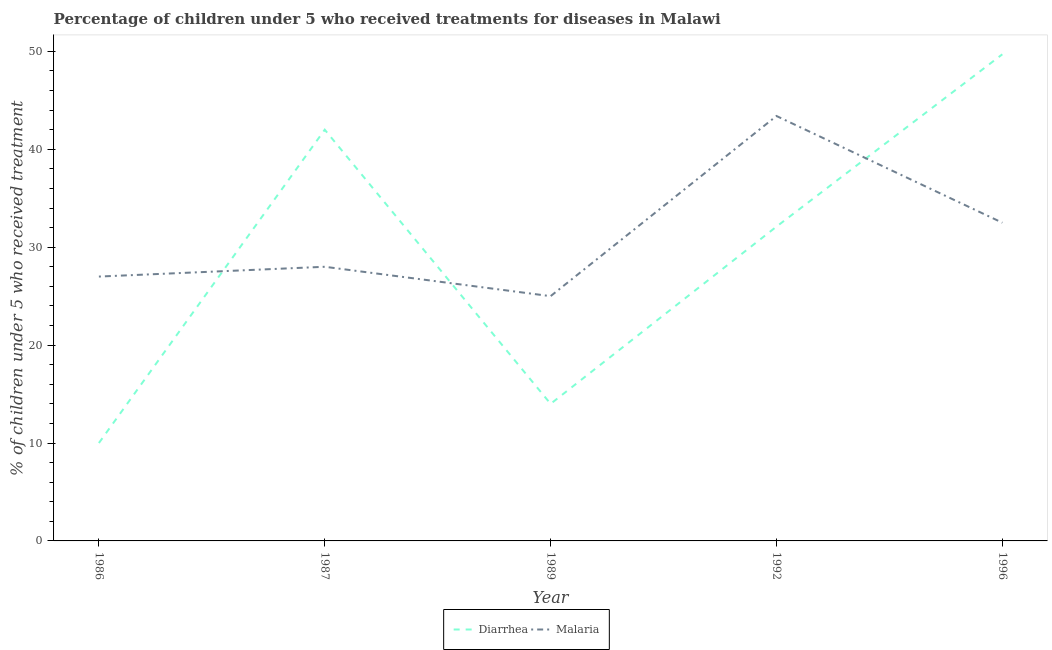Does the line corresponding to percentage of children who received treatment for malaria intersect with the line corresponding to percentage of children who received treatment for diarrhoea?
Offer a very short reply. Yes. What is the percentage of children who received treatment for diarrhoea in 1992?
Your answer should be very brief. 32.1. Across all years, what is the maximum percentage of children who received treatment for diarrhoea?
Provide a short and direct response. 49.7. In which year was the percentage of children who received treatment for diarrhoea minimum?
Your answer should be compact. 1986. What is the total percentage of children who received treatment for diarrhoea in the graph?
Provide a succinct answer. 147.8. What is the difference between the percentage of children who received treatment for malaria in 1989 and the percentage of children who received treatment for diarrhoea in 1992?
Ensure brevity in your answer.  -7.1. What is the average percentage of children who received treatment for diarrhoea per year?
Keep it short and to the point. 29.56. What is the ratio of the percentage of children who received treatment for diarrhoea in 1987 to that in 1996?
Make the answer very short. 0.85. Is the percentage of children who received treatment for diarrhoea in 1987 less than that in 1992?
Your answer should be compact. No. Is the difference between the percentage of children who received treatment for diarrhoea in 1989 and 1996 greater than the difference between the percentage of children who received treatment for malaria in 1989 and 1996?
Provide a short and direct response. No. What is the difference between the highest and the second highest percentage of children who received treatment for malaria?
Offer a very short reply. 10.9. What is the difference between the highest and the lowest percentage of children who received treatment for malaria?
Offer a terse response. 18.4. Does the percentage of children who received treatment for malaria monotonically increase over the years?
Provide a succinct answer. No. Is the percentage of children who received treatment for diarrhoea strictly less than the percentage of children who received treatment for malaria over the years?
Ensure brevity in your answer.  No. How many lines are there?
Provide a succinct answer. 2. Are the values on the major ticks of Y-axis written in scientific E-notation?
Offer a terse response. No. Does the graph contain any zero values?
Give a very brief answer. No. Where does the legend appear in the graph?
Provide a short and direct response. Bottom center. What is the title of the graph?
Provide a short and direct response. Percentage of children under 5 who received treatments for diseases in Malawi. What is the label or title of the Y-axis?
Offer a terse response. % of children under 5 who received treatment. What is the % of children under 5 who received treatment of Diarrhea in 1986?
Provide a succinct answer. 10. What is the % of children under 5 who received treatment of Diarrhea in 1987?
Provide a succinct answer. 42. What is the % of children under 5 who received treatment in Diarrhea in 1992?
Your answer should be compact. 32.1. What is the % of children under 5 who received treatment of Malaria in 1992?
Provide a succinct answer. 43.4. What is the % of children under 5 who received treatment of Diarrhea in 1996?
Your answer should be compact. 49.7. What is the % of children under 5 who received treatment of Malaria in 1996?
Your response must be concise. 32.5. Across all years, what is the maximum % of children under 5 who received treatment of Diarrhea?
Keep it short and to the point. 49.7. Across all years, what is the maximum % of children under 5 who received treatment in Malaria?
Ensure brevity in your answer.  43.4. Across all years, what is the minimum % of children under 5 who received treatment in Diarrhea?
Offer a very short reply. 10. What is the total % of children under 5 who received treatment in Diarrhea in the graph?
Your response must be concise. 147.8. What is the total % of children under 5 who received treatment of Malaria in the graph?
Make the answer very short. 155.9. What is the difference between the % of children under 5 who received treatment of Diarrhea in 1986 and that in 1987?
Provide a short and direct response. -32. What is the difference between the % of children under 5 who received treatment of Diarrhea in 1986 and that in 1989?
Provide a succinct answer. -4. What is the difference between the % of children under 5 who received treatment of Malaria in 1986 and that in 1989?
Offer a very short reply. 2. What is the difference between the % of children under 5 who received treatment of Diarrhea in 1986 and that in 1992?
Make the answer very short. -22.1. What is the difference between the % of children under 5 who received treatment of Malaria in 1986 and that in 1992?
Offer a terse response. -16.4. What is the difference between the % of children under 5 who received treatment of Diarrhea in 1986 and that in 1996?
Keep it short and to the point. -39.7. What is the difference between the % of children under 5 who received treatment in Diarrhea in 1987 and that in 1989?
Ensure brevity in your answer.  28. What is the difference between the % of children under 5 who received treatment in Malaria in 1987 and that in 1989?
Ensure brevity in your answer.  3. What is the difference between the % of children under 5 who received treatment of Diarrhea in 1987 and that in 1992?
Give a very brief answer. 9.9. What is the difference between the % of children under 5 who received treatment of Malaria in 1987 and that in 1992?
Provide a succinct answer. -15.4. What is the difference between the % of children under 5 who received treatment of Diarrhea in 1987 and that in 1996?
Ensure brevity in your answer.  -7.7. What is the difference between the % of children under 5 who received treatment of Malaria in 1987 and that in 1996?
Your response must be concise. -4.5. What is the difference between the % of children under 5 who received treatment of Diarrhea in 1989 and that in 1992?
Your answer should be compact. -18.1. What is the difference between the % of children under 5 who received treatment of Malaria in 1989 and that in 1992?
Your answer should be compact. -18.4. What is the difference between the % of children under 5 who received treatment in Diarrhea in 1989 and that in 1996?
Offer a terse response. -35.7. What is the difference between the % of children under 5 who received treatment of Diarrhea in 1992 and that in 1996?
Your response must be concise. -17.6. What is the difference between the % of children under 5 who received treatment in Malaria in 1992 and that in 1996?
Provide a short and direct response. 10.9. What is the difference between the % of children under 5 who received treatment in Diarrhea in 1986 and the % of children under 5 who received treatment in Malaria in 1992?
Offer a very short reply. -33.4. What is the difference between the % of children under 5 who received treatment of Diarrhea in 1986 and the % of children under 5 who received treatment of Malaria in 1996?
Keep it short and to the point. -22.5. What is the difference between the % of children under 5 who received treatment in Diarrhea in 1987 and the % of children under 5 who received treatment in Malaria in 1989?
Your response must be concise. 17. What is the difference between the % of children under 5 who received treatment in Diarrhea in 1987 and the % of children under 5 who received treatment in Malaria in 1996?
Your answer should be very brief. 9.5. What is the difference between the % of children under 5 who received treatment of Diarrhea in 1989 and the % of children under 5 who received treatment of Malaria in 1992?
Ensure brevity in your answer.  -29.4. What is the difference between the % of children under 5 who received treatment of Diarrhea in 1989 and the % of children under 5 who received treatment of Malaria in 1996?
Offer a terse response. -18.5. What is the average % of children under 5 who received treatment in Diarrhea per year?
Provide a short and direct response. 29.56. What is the average % of children under 5 who received treatment of Malaria per year?
Your response must be concise. 31.18. In the year 1987, what is the difference between the % of children under 5 who received treatment in Diarrhea and % of children under 5 who received treatment in Malaria?
Provide a succinct answer. 14. What is the ratio of the % of children under 5 who received treatment in Diarrhea in 1986 to that in 1987?
Your response must be concise. 0.24. What is the ratio of the % of children under 5 who received treatment in Malaria in 1986 to that in 1987?
Offer a terse response. 0.96. What is the ratio of the % of children under 5 who received treatment in Diarrhea in 1986 to that in 1989?
Keep it short and to the point. 0.71. What is the ratio of the % of children under 5 who received treatment of Malaria in 1986 to that in 1989?
Keep it short and to the point. 1.08. What is the ratio of the % of children under 5 who received treatment in Diarrhea in 1986 to that in 1992?
Ensure brevity in your answer.  0.31. What is the ratio of the % of children under 5 who received treatment of Malaria in 1986 to that in 1992?
Your answer should be compact. 0.62. What is the ratio of the % of children under 5 who received treatment of Diarrhea in 1986 to that in 1996?
Offer a very short reply. 0.2. What is the ratio of the % of children under 5 who received treatment in Malaria in 1986 to that in 1996?
Keep it short and to the point. 0.83. What is the ratio of the % of children under 5 who received treatment of Malaria in 1987 to that in 1989?
Keep it short and to the point. 1.12. What is the ratio of the % of children under 5 who received treatment in Diarrhea in 1987 to that in 1992?
Offer a very short reply. 1.31. What is the ratio of the % of children under 5 who received treatment in Malaria in 1987 to that in 1992?
Provide a short and direct response. 0.65. What is the ratio of the % of children under 5 who received treatment of Diarrhea in 1987 to that in 1996?
Provide a succinct answer. 0.85. What is the ratio of the % of children under 5 who received treatment in Malaria in 1987 to that in 1996?
Provide a succinct answer. 0.86. What is the ratio of the % of children under 5 who received treatment of Diarrhea in 1989 to that in 1992?
Your response must be concise. 0.44. What is the ratio of the % of children under 5 who received treatment in Malaria in 1989 to that in 1992?
Ensure brevity in your answer.  0.58. What is the ratio of the % of children under 5 who received treatment in Diarrhea in 1989 to that in 1996?
Keep it short and to the point. 0.28. What is the ratio of the % of children under 5 who received treatment of Malaria in 1989 to that in 1996?
Your answer should be compact. 0.77. What is the ratio of the % of children under 5 who received treatment in Diarrhea in 1992 to that in 1996?
Offer a terse response. 0.65. What is the ratio of the % of children under 5 who received treatment of Malaria in 1992 to that in 1996?
Ensure brevity in your answer.  1.34. What is the difference between the highest and the second highest % of children under 5 who received treatment in Malaria?
Provide a short and direct response. 10.9. What is the difference between the highest and the lowest % of children under 5 who received treatment in Diarrhea?
Give a very brief answer. 39.7. 